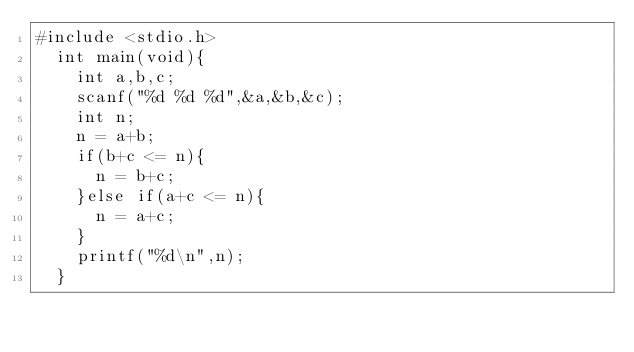<code> <loc_0><loc_0><loc_500><loc_500><_C_>#include <stdio.h>
  int main(void){
    int a,b,c;
    scanf("%d %d %d",&a,&b,&c);
    int n;
    n = a+b;
    if(b+c <= n){
      n = b+c;
    }else if(a+c <= n){
      n = a+c;
    }
    printf("%d\n",n);
  }</code> 